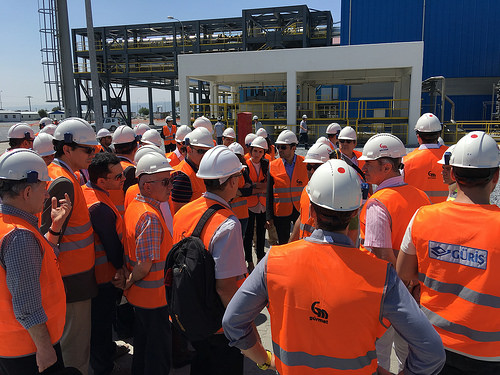<image>
Is the helmet on the man? No. The helmet is not positioned on the man. They may be near each other, but the helmet is not supported by or resting on top of the man. Is there a person next to the building? No. The person is not positioned next to the building. They are located in different areas of the scene. 